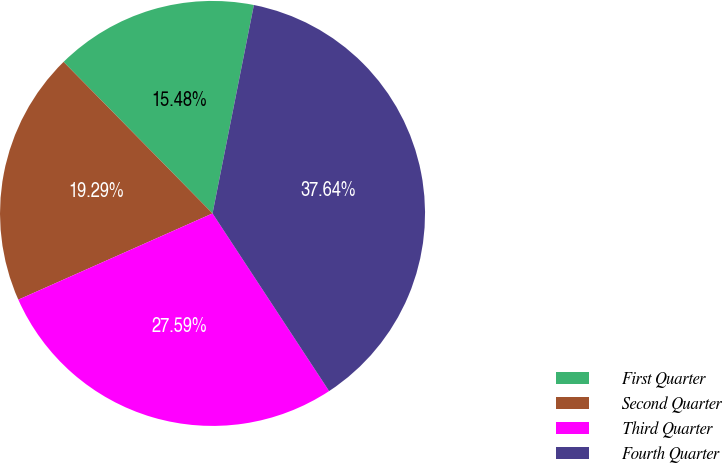Convert chart. <chart><loc_0><loc_0><loc_500><loc_500><pie_chart><fcel>First Quarter<fcel>Second Quarter<fcel>Third Quarter<fcel>Fourth Quarter<nl><fcel>15.48%<fcel>19.29%<fcel>27.59%<fcel>37.64%<nl></chart> 